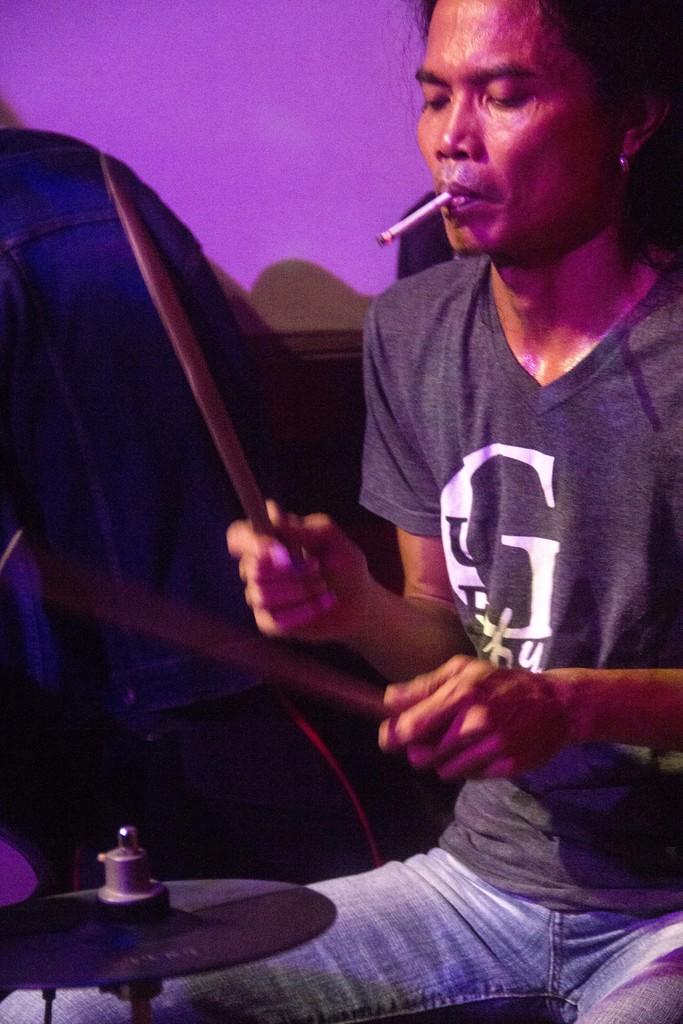What brand is the shirt the man is wearing?
Your response must be concise. Unanswerable. What big white letter is on the man's shirt?
Give a very brief answer. G. 